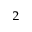Convert formula to latex. <formula><loc_0><loc_0><loc_500><loc_500>^ { 2 }</formula> 